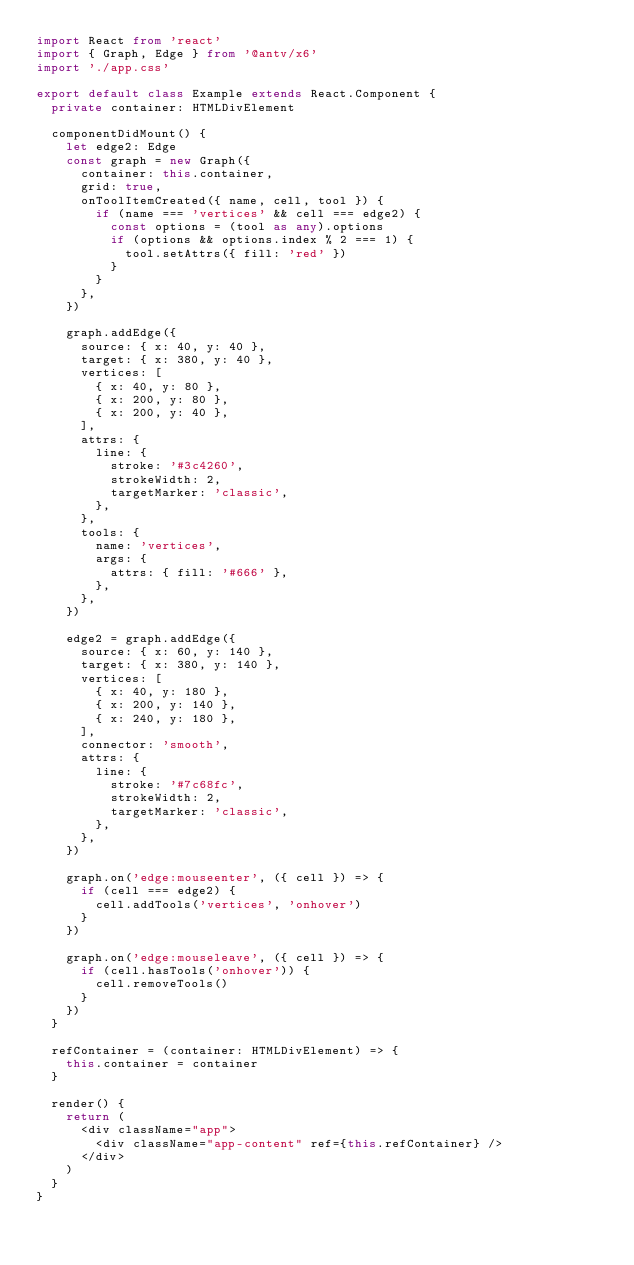<code> <loc_0><loc_0><loc_500><loc_500><_TypeScript_>import React from 'react'
import { Graph, Edge } from '@antv/x6'
import './app.css'

export default class Example extends React.Component {
  private container: HTMLDivElement

  componentDidMount() {
    let edge2: Edge
    const graph = new Graph({
      container: this.container,
      grid: true,
      onToolItemCreated({ name, cell, tool }) {
        if (name === 'vertices' && cell === edge2) {
          const options = (tool as any).options
          if (options && options.index % 2 === 1) {
            tool.setAttrs({ fill: 'red' })
          }
        }
      },
    })

    graph.addEdge({
      source: { x: 40, y: 40 },
      target: { x: 380, y: 40 },
      vertices: [
        { x: 40, y: 80 },
        { x: 200, y: 80 },
        { x: 200, y: 40 },
      ],
      attrs: {
        line: {
          stroke: '#3c4260',
          strokeWidth: 2,
          targetMarker: 'classic',
        },
      },
      tools: {
        name: 'vertices',
        args: {
          attrs: { fill: '#666' },
        },
      },
    })

    edge2 = graph.addEdge({
      source: { x: 60, y: 140 },
      target: { x: 380, y: 140 },
      vertices: [
        { x: 40, y: 180 },
        { x: 200, y: 140 },
        { x: 240, y: 180 },
      ],
      connector: 'smooth',
      attrs: {
        line: {
          stroke: '#7c68fc',
          strokeWidth: 2,
          targetMarker: 'classic',
        },
      },
    })

    graph.on('edge:mouseenter', ({ cell }) => {
      if (cell === edge2) {
        cell.addTools('vertices', 'onhover')
      }
    })

    graph.on('edge:mouseleave', ({ cell }) => {
      if (cell.hasTools('onhover')) {
        cell.removeTools()
      }
    })
  }

  refContainer = (container: HTMLDivElement) => {
    this.container = container
  }

  render() {
    return (
      <div className="app">
        <div className="app-content" ref={this.refContainer} />
      </div>
    )
  }
}
</code> 